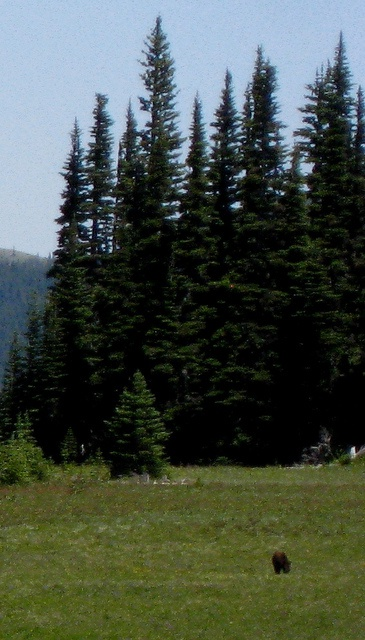Describe the objects in this image and their specific colors. I can see a bear in lightblue, black, darkgreen, maroon, and olive tones in this image. 